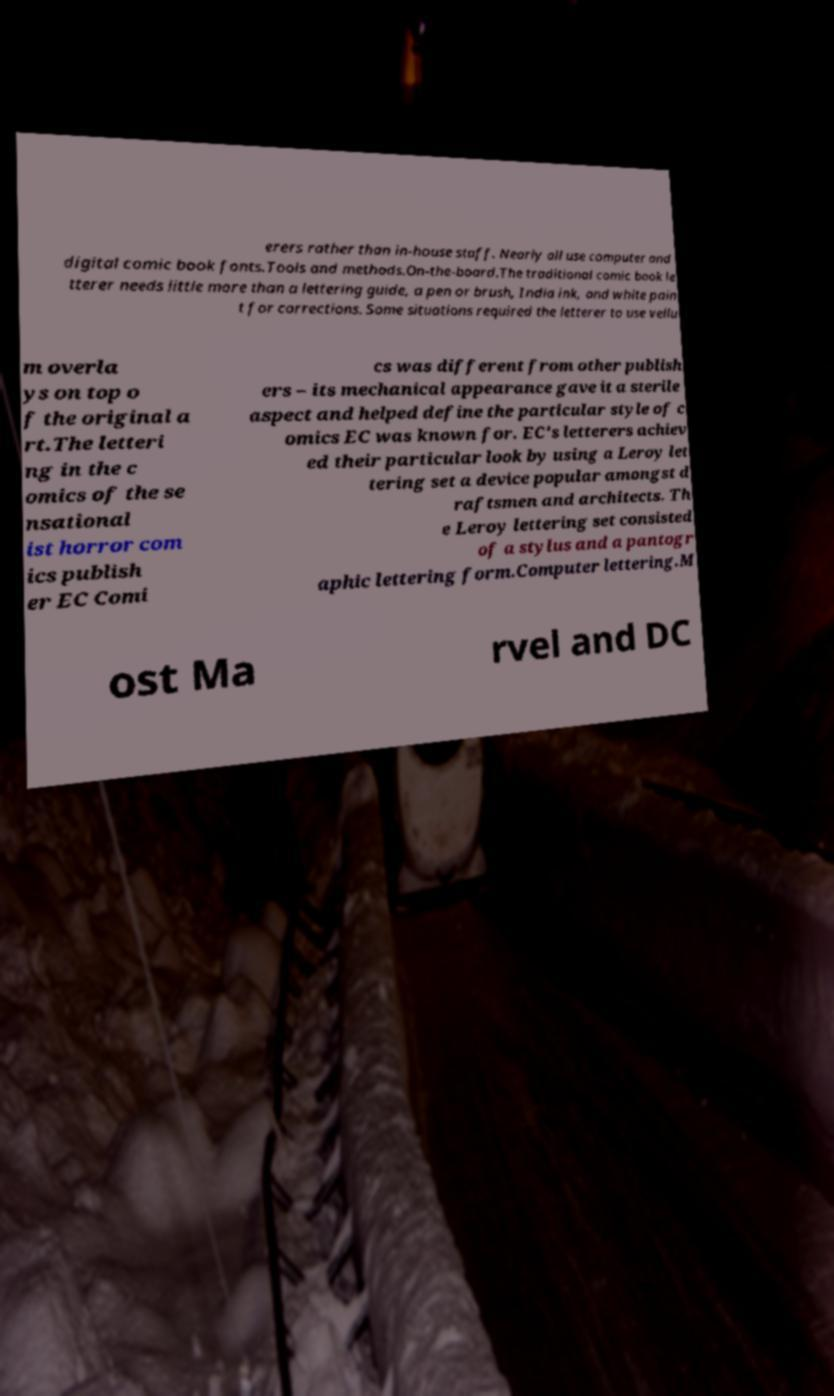Please read and relay the text visible in this image. What does it say? erers rather than in-house staff. Nearly all use computer and digital comic book fonts.Tools and methods.On-the-board.The traditional comic book le tterer needs little more than a lettering guide, a pen or brush, India ink, and white pain t for corrections. Some situations required the letterer to use vellu m overla ys on top o f the original a rt.The letteri ng in the c omics of the se nsational ist horror com ics publish er EC Comi cs was different from other publish ers – its mechanical appearance gave it a sterile aspect and helped define the particular style of c omics EC was known for. EC's letterers achiev ed their particular look by using a Leroy let tering set a device popular amongst d raftsmen and architects. Th e Leroy lettering set consisted of a stylus and a pantogr aphic lettering form.Computer lettering.M ost Ma rvel and DC 